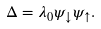Convert formula to latex. <formula><loc_0><loc_0><loc_500><loc_500>\Delta = \lambda _ { 0 } \psi _ { \downarrow } \psi _ { \uparrow } .</formula> 